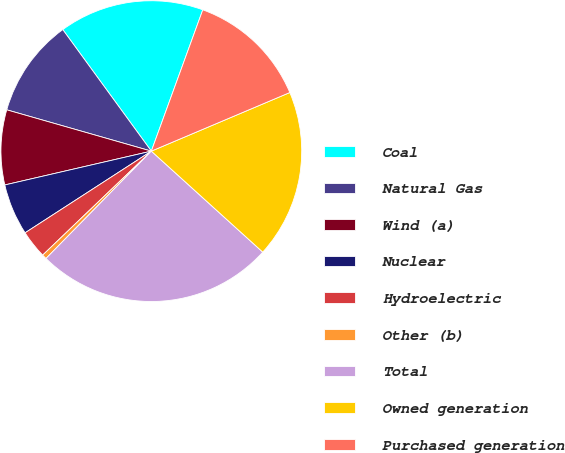Convert chart to OTSL. <chart><loc_0><loc_0><loc_500><loc_500><pie_chart><fcel>Coal<fcel>Natural Gas<fcel>Wind (a)<fcel>Nuclear<fcel>Hydroelectric<fcel>Other (b)<fcel>Total<fcel>Owned generation<fcel>Purchased generation<nl><fcel>15.58%<fcel>10.55%<fcel>8.04%<fcel>5.53%<fcel>3.01%<fcel>0.5%<fcel>25.63%<fcel>18.09%<fcel>13.07%<nl></chart> 